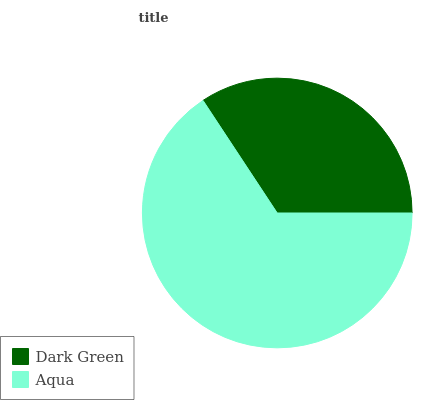Is Dark Green the minimum?
Answer yes or no. Yes. Is Aqua the maximum?
Answer yes or no. Yes. Is Aqua the minimum?
Answer yes or no. No. Is Aqua greater than Dark Green?
Answer yes or no. Yes. Is Dark Green less than Aqua?
Answer yes or no. Yes. Is Dark Green greater than Aqua?
Answer yes or no. No. Is Aqua less than Dark Green?
Answer yes or no. No. Is Aqua the high median?
Answer yes or no. Yes. Is Dark Green the low median?
Answer yes or no. Yes. Is Dark Green the high median?
Answer yes or no. No. Is Aqua the low median?
Answer yes or no. No. 